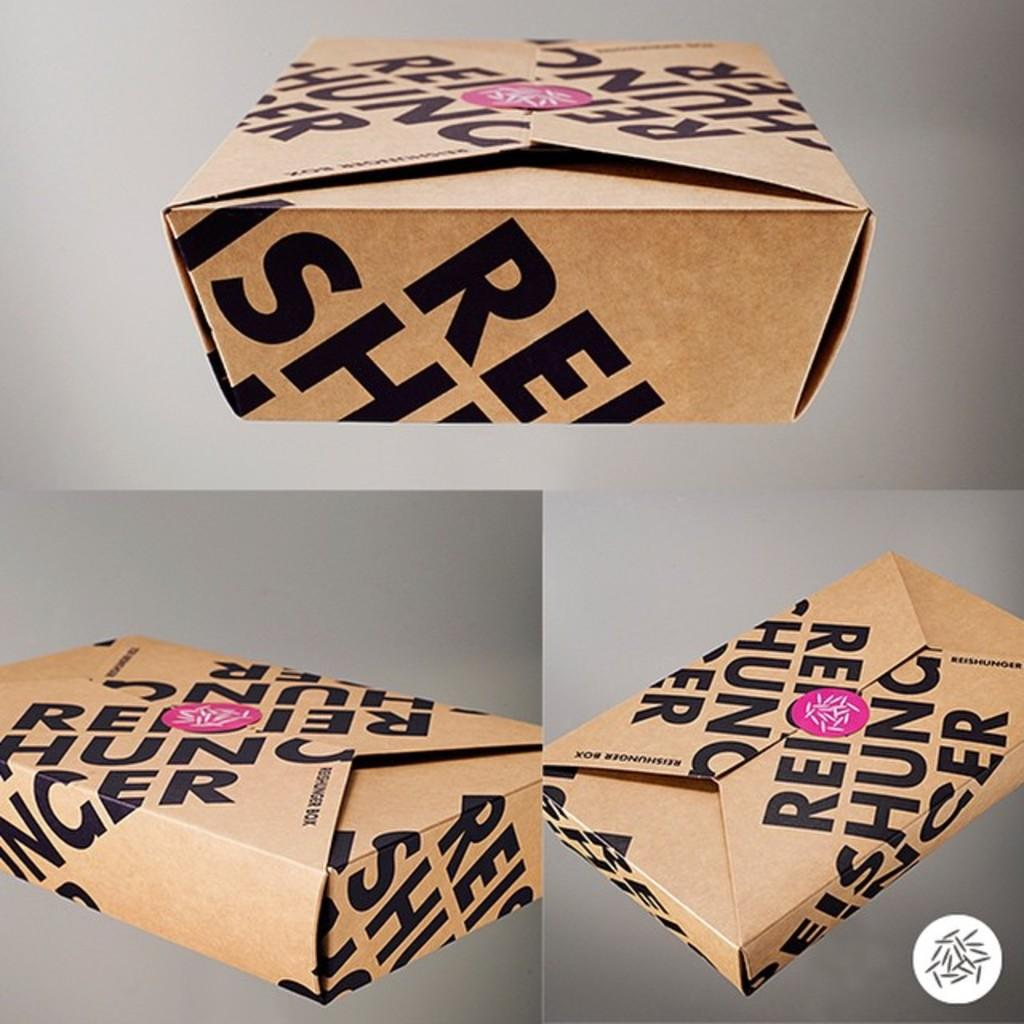Provide a one-sentence caption for the provided image. A box has a pink sticker on it and is labelled Reischung. 